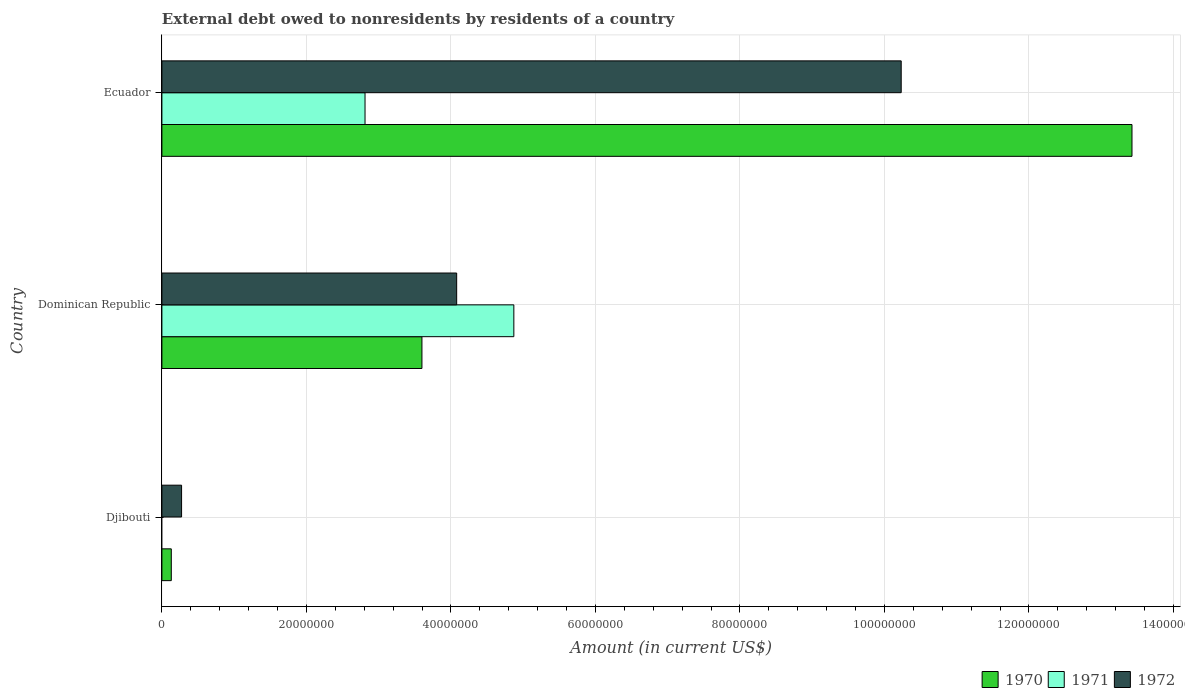How many different coloured bars are there?
Keep it short and to the point. 3. How many bars are there on the 2nd tick from the bottom?
Ensure brevity in your answer.  3. What is the label of the 3rd group of bars from the top?
Make the answer very short. Djibouti. What is the external debt owed by residents in 1972 in Ecuador?
Your response must be concise. 1.02e+08. Across all countries, what is the maximum external debt owed by residents in 1971?
Keep it short and to the point. 4.87e+07. Across all countries, what is the minimum external debt owed by residents in 1971?
Offer a very short reply. 0. In which country was the external debt owed by residents in 1970 maximum?
Your response must be concise. Ecuador. What is the total external debt owed by residents in 1970 in the graph?
Ensure brevity in your answer.  1.72e+08. What is the difference between the external debt owed by residents in 1971 in Dominican Republic and that in Ecuador?
Your response must be concise. 2.06e+07. What is the difference between the external debt owed by residents in 1971 in Djibouti and the external debt owed by residents in 1972 in Dominican Republic?
Ensure brevity in your answer.  -4.08e+07. What is the average external debt owed by residents in 1972 per country?
Offer a terse response. 4.86e+07. What is the difference between the external debt owed by residents in 1972 and external debt owed by residents in 1970 in Dominican Republic?
Keep it short and to the point. 4.81e+06. In how many countries, is the external debt owed by residents in 1972 greater than 36000000 US$?
Offer a very short reply. 2. What is the ratio of the external debt owed by residents in 1972 in Djibouti to that in Ecuador?
Offer a terse response. 0.03. What is the difference between the highest and the second highest external debt owed by residents in 1972?
Provide a short and direct response. 6.15e+07. What is the difference between the highest and the lowest external debt owed by residents in 1972?
Provide a succinct answer. 9.96e+07. Is the sum of the external debt owed by residents in 1972 in Djibouti and Dominican Republic greater than the maximum external debt owed by residents in 1970 across all countries?
Your response must be concise. No. How many bars are there?
Your answer should be very brief. 8. What is the difference between two consecutive major ticks on the X-axis?
Your answer should be compact. 2.00e+07. What is the title of the graph?
Your response must be concise. External debt owed to nonresidents by residents of a country. What is the label or title of the X-axis?
Keep it short and to the point. Amount (in current US$). What is the label or title of the Y-axis?
Offer a very short reply. Country. What is the Amount (in current US$) of 1970 in Djibouti?
Make the answer very short. 1.30e+06. What is the Amount (in current US$) in 1971 in Djibouti?
Your response must be concise. 0. What is the Amount (in current US$) of 1972 in Djibouti?
Ensure brevity in your answer.  2.72e+06. What is the Amount (in current US$) in 1970 in Dominican Republic?
Make the answer very short. 3.60e+07. What is the Amount (in current US$) of 1971 in Dominican Republic?
Give a very brief answer. 4.87e+07. What is the Amount (in current US$) in 1972 in Dominican Republic?
Provide a short and direct response. 4.08e+07. What is the Amount (in current US$) of 1970 in Ecuador?
Give a very brief answer. 1.34e+08. What is the Amount (in current US$) in 1971 in Ecuador?
Make the answer very short. 2.81e+07. What is the Amount (in current US$) in 1972 in Ecuador?
Offer a very short reply. 1.02e+08. Across all countries, what is the maximum Amount (in current US$) in 1970?
Your answer should be compact. 1.34e+08. Across all countries, what is the maximum Amount (in current US$) of 1971?
Your response must be concise. 4.87e+07. Across all countries, what is the maximum Amount (in current US$) of 1972?
Provide a succinct answer. 1.02e+08. Across all countries, what is the minimum Amount (in current US$) in 1970?
Your answer should be very brief. 1.30e+06. Across all countries, what is the minimum Amount (in current US$) of 1972?
Make the answer very short. 2.72e+06. What is the total Amount (in current US$) of 1970 in the graph?
Offer a very short reply. 1.72e+08. What is the total Amount (in current US$) in 1971 in the graph?
Your answer should be compact. 7.68e+07. What is the total Amount (in current US$) in 1972 in the graph?
Give a very brief answer. 1.46e+08. What is the difference between the Amount (in current US$) of 1970 in Djibouti and that in Dominican Republic?
Your answer should be very brief. -3.47e+07. What is the difference between the Amount (in current US$) in 1972 in Djibouti and that in Dominican Republic?
Make the answer very short. -3.81e+07. What is the difference between the Amount (in current US$) of 1970 in Djibouti and that in Ecuador?
Your answer should be very brief. -1.33e+08. What is the difference between the Amount (in current US$) in 1972 in Djibouti and that in Ecuador?
Offer a very short reply. -9.96e+07. What is the difference between the Amount (in current US$) of 1970 in Dominican Republic and that in Ecuador?
Your response must be concise. -9.83e+07. What is the difference between the Amount (in current US$) of 1971 in Dominican Republic and that in Ecuador?
Offer a very short reply. 2.06e+07. What is the difference between the Amount (in current US$) of 1972 in Dominican Republic and that in Ecuador?
Give a very brief answer. -6.15e+07. What is the difference between the Amount (in current US$) of 1970 in Djibouti and the Amount (in current US$) of 1971 in Dominican Republic?
Ensure brevity in your answer.  -4.74e+07. What is the difference between the Amount (in current US$) of 1970 in Djibouti and the Amount (in current US$) of 1972 in Dominican Republic?
Provide a succinct answer. -3.95e+07. What is the difference between the Amount (in current US$) of 1970 in Djibouti and the Amount (in current US$) of 1971 in Ecuador?
Ensure brevity in your answer.  -2.68e+07. What is the difference between the Amount (in current US$) of 1970 in Djibouti and the Amount (in current US$) of 1972 in Ecuador?
Your answer should be compact. -1.01e+08. What is the difference between the Amount (in current US$) in 1970 in Dominican Republic and the Amount (in current US$) in 1971 in Ecuador?
Offer a very short reply. 7.88e+06. What is the difference between the Amount (in current US$) in 1970 in Dominican Republic and the Amount (in current US$) in 1972 in Ecuador?
Your answer should be compact. -6.63e+07. What is the difference between the Amount (in current US$) in 1971 in Dominican Republic and the Amount (in current US$) in 1972 in Ecuador?
Offer a terse response. -5.36e+07. What is the average Amount (in current US$) in 1970 per country?
Provide a succinct answer. 5.72e+07. What is the average Amount (in current US$) in 1971 per country?
Your response must be concise. 2.56e+07. What is the average Amount (in current US$) of 1972 per country?
Ensure brevity in your answer.  4.86e+07. What is the difference between the Amount (in current US$) in 1970 and Amount (in current US$) in 1972 in Djibouti?
Give a very brief answer. -1.42e+06. What is the difference between the Amount (in current US$) in 1970 and Amount (in current US$) in 1971 in Dominican Republic?
Give a very brief answer. -1.27e+07. What is the difference between the Amount (in current US$) in 1970 and Amount (in current US$) in 1972 in Dominican Republic?
Your answer should be compact. -4.81e+06. What is the difference between the Amount (in current US$) in 1971 and Amount (in current US$) in 1972 in Dominican Republic?
Offer a very short reply. 7.91e+06. What is the difference between the Amount (in current US$) in 1970 and Amount (in current US$) in 1971 in Ecuador?
Keep it short and to the point. 1.06e+08. What is the difference between the Amount (in current US$) of 1970 and Amount (in current US$) of 1972 in Ecuador?
Offer a terse response. 3.19e+07. What is the difference between the Amount (in current US$) in 1971 and Amount (in current US$) in 1972 in Ecuador?
Your response must be concise. -7.42e+07. What is the ratio of the Amount (in current US$) in 1970 in Djibouti to that in Dominican Republic?
Keep it short and to the point. 0.04. What is the ratio of the Amount (in current US$) in 1972 in Djibouti to that in Dominican Republic?
Offer a terse response. 0.07. What is the ratio of the Amount (in current US$) in 1970 in Djibouti to that in Ecuador?
Keep it short and to the point. 0.01. What is the ratio of the Amount (in current US$) of 1972 in Djibouti to that in Ecuador?
Ensure brevity in your answer.  0.03. What is the ratio of the Amount (in current US$) of 1970 in Dominican Republic to that in Ecuador?
Offer a very short reply. 0.27. What is the ratio of the Amount (in current US$) in 1971 in Dominican Republic to that in Ecuador?
Keep it short and to the point. 1.73. What is the ratio of the Amount (in current US$) of 1972 in Dominican Republic to that in Ecuador?
Keep it short and to the point. 0.4. What is the difference between the highest and the second highest Amount (in current US$) in 1970?
Offer a terse response. 9.83e+07. What is the difference between the highest and the second highest Amount (in current US$) of 1972?
Ensure brevity in your answer.  6.15e+07. What is the difference between the highest and the lowest Amount (in current US$) of 1970?
Keep it short and to the point. 1.33e+08. What is the difference between the highest and the lowest Amount (in current US$) of 1971?
Keep it short and to the point. 4.87e+07. What is the difference between the highest and the lowest Amount (in current US$) of 1972?
Give a very brief answer. 9.96e+07. 